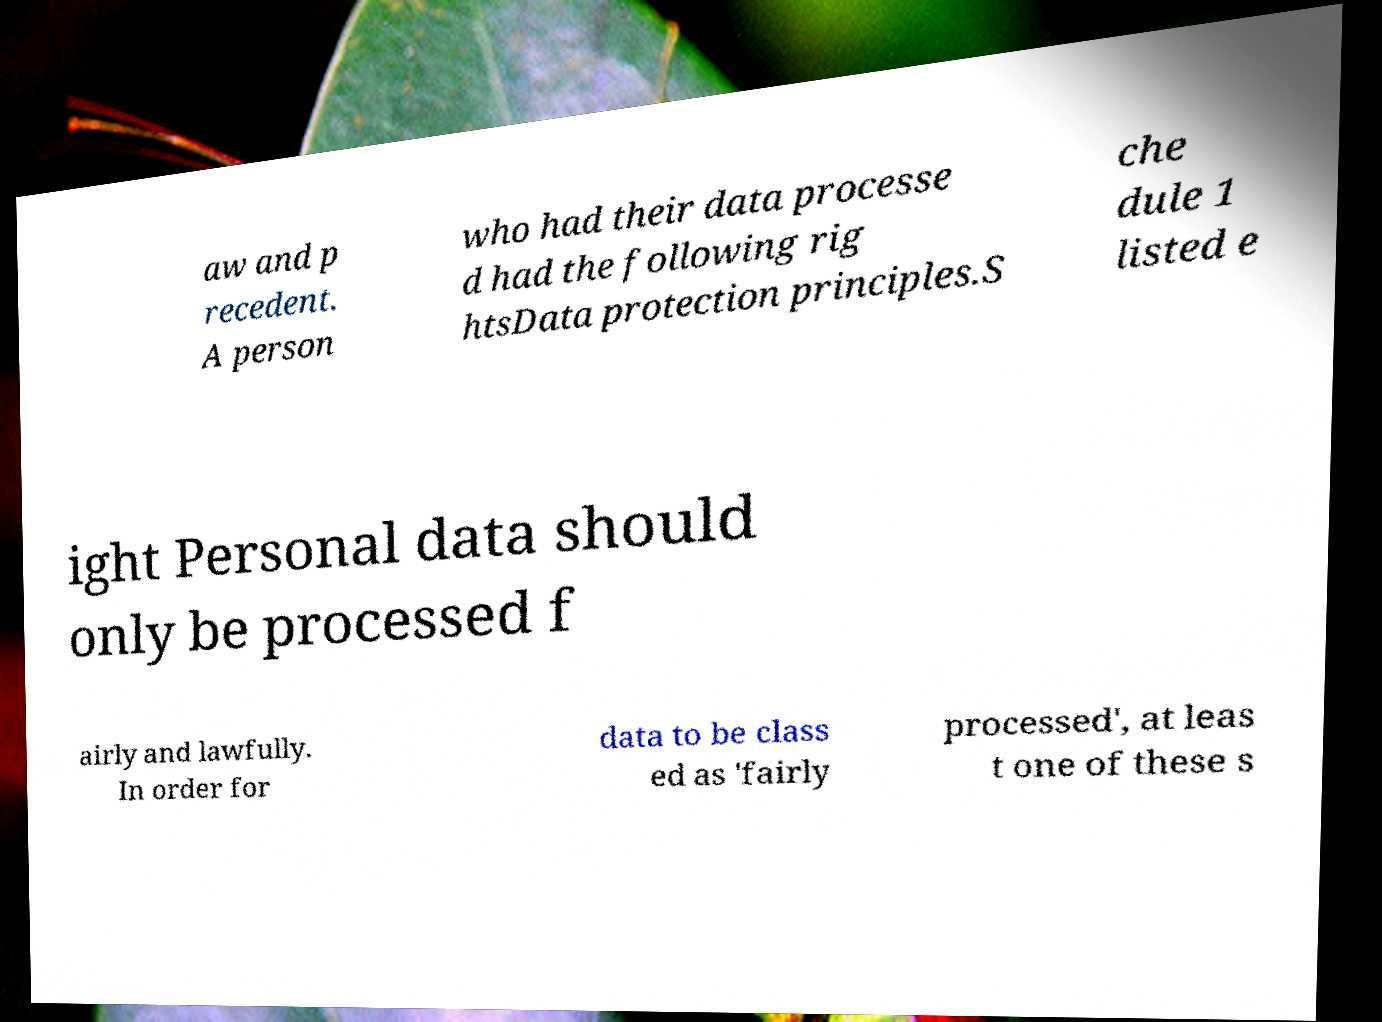Can you read and provide the text displayed in the image?This photo seems to have some interesting text. Can you extract and type it out for me? aw and p recedent. A person who had their data processe d had the following rig htsData protection principles.S che dule 1 listed e ight Personal data should only be processed f airly and lawfully. In order for data to be class ed as 'fairly processed', at leas t one of these s 